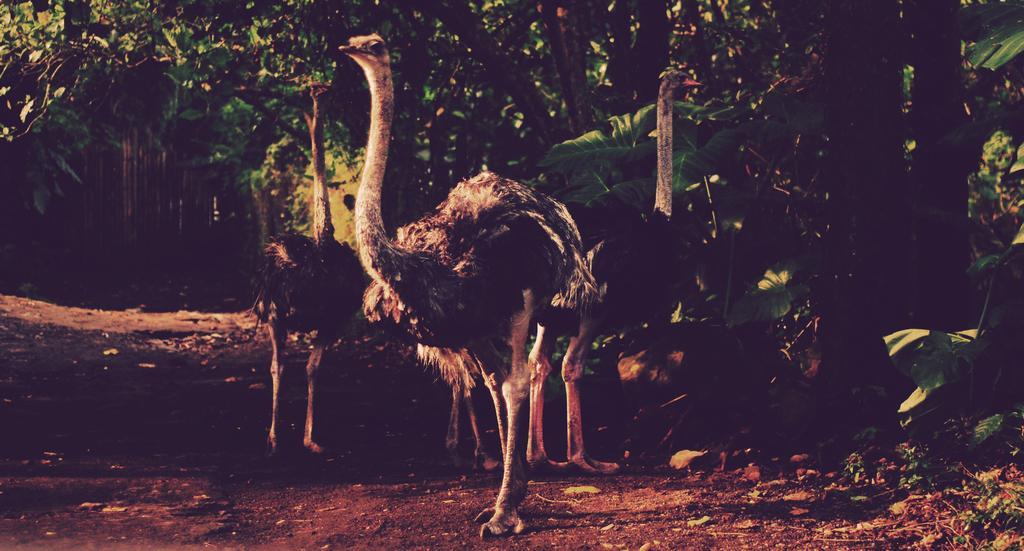Please provide a concise description of this image. In this image in the center three ostriches and in the background there are a group of trees, at the bottom there is sand and some dry leaves and grass. 